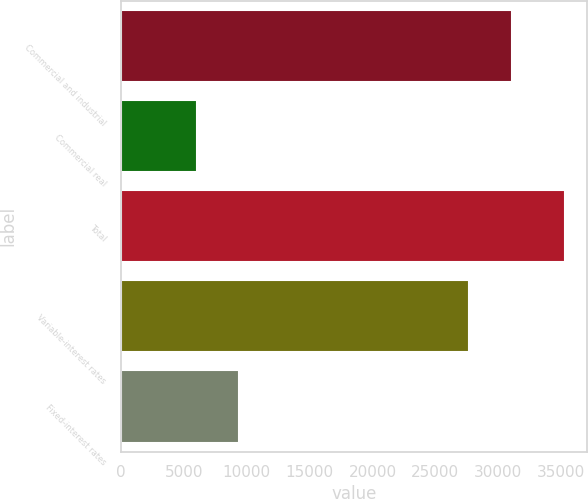Convert chart. <chart><loc_0><loc_0><loc_500><loc_500><bar_chart><fcel>Commercial and industrial<fcel>Commercial real<fcel>Total<fcel>Variable-interest rates<fcel>Fixed-interest rates<nl><fcel>31062.5<fcel>6008<fcel>35332<fcel>27651<fcel>9419.5<nl></chart> 